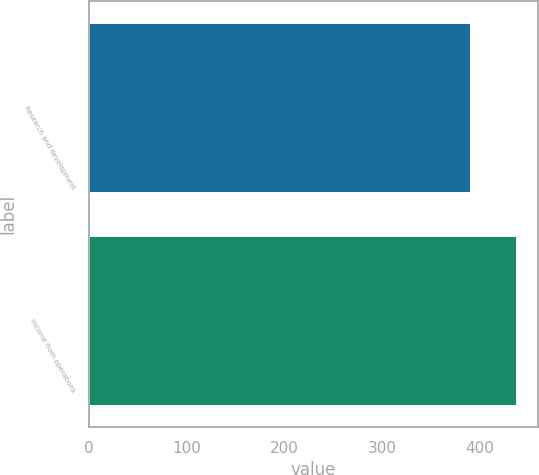<chart> <loc_0><loc_0><loc_500><loc_500><bar_chart><fcel>Research and development<fcel>Income from operations<nl><fcel>391<fcel>438<nl></chart> 